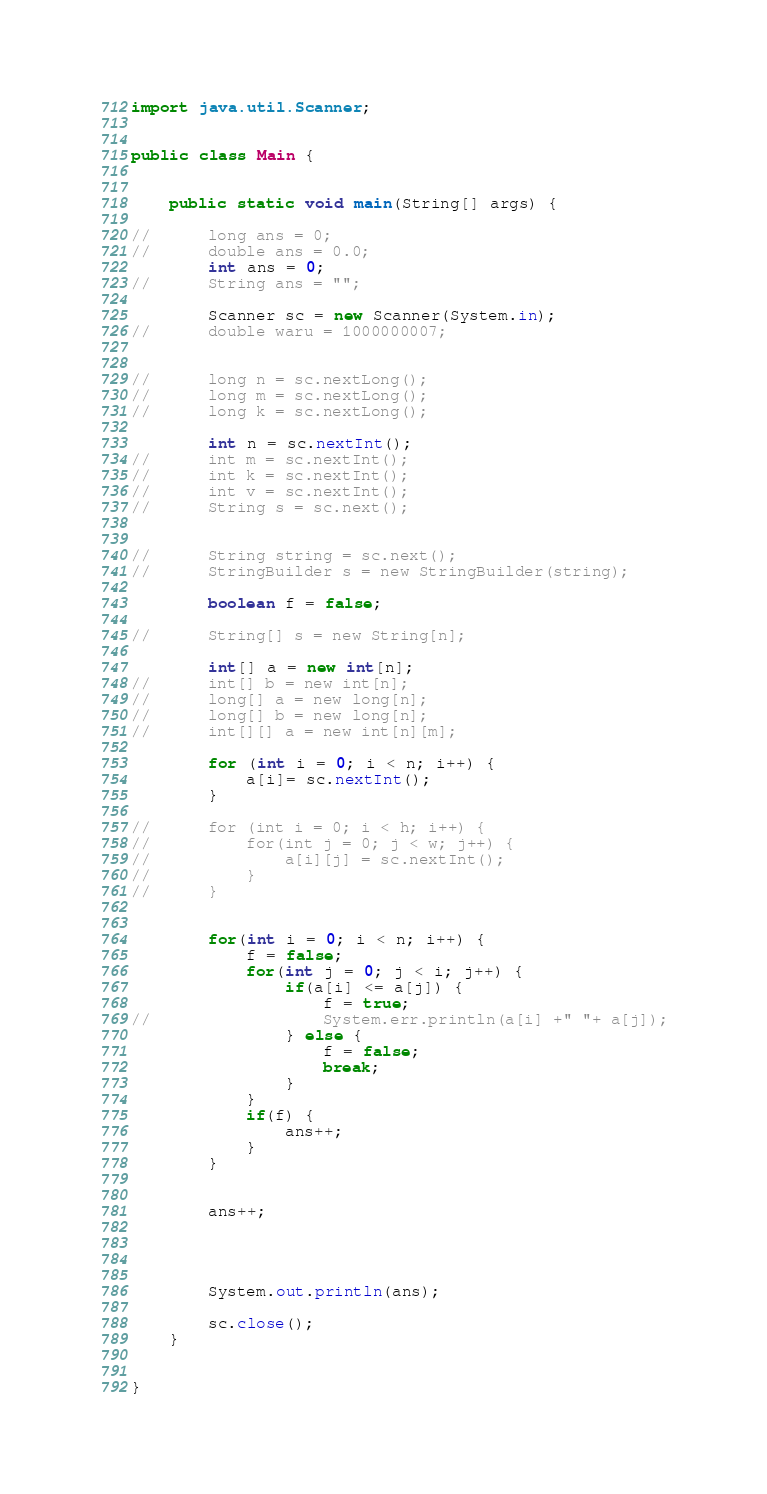Convert code to text. <code><loc_0><loc_0><loc_500><loc_500><_Java_>import java.util.Scanner;


public class Main {


	public static void main(String[] args) {

//		long ans = 0;
//		double ans = 0.0;
		int ans = 0;
//		String ans = "";

		Scanner sc = new Scanner(System.in);
//		double waru = 1000000007;


//		long n = sc.nextLong();
//		long m = sc.nextLong();
//		long k = sc.nextLong();

		int n = sc.nextInt();
//		int m = sc.nextInt();
//		int k = sc.nextInt();
//		int v = sc.nextInt();
//		String s = sc.next();


//		String string = sc.next();
//		StringBuilder s = new StringBuilder(string);

		boolean f = false;

//		String[] s = new String[n];

		int[] a = new int[n];
//		int[] b = new int[n];
//		long[] a = new long[n];
//		long[] b = new long[n];
//		int[][] a = new int[n][m];

		for (int i = 0; i < n; i++) {
			a[i]= sc.nextInt();
		}

//		for (int i = 0; i < h; i++) {
//			for(int j = 0; j < w; j++) {
//				a[i][j] = sc.nextInt();
//			}
//		}


		for(int i = 0; i < n; i++) {
			f = false;
			for(int j = 0; j < i; j++) {
				if(a[i] <= a[j]) {
					f = true;
//					System.err.println(a[i] +" "+ a[j]);
				} else {
					f = false;
					break;
				}
			}
			if(f) {
				ans++;
			}
		}


		ans++;




		System.out.println(ans);

		sc.close();
	}


}</code> 